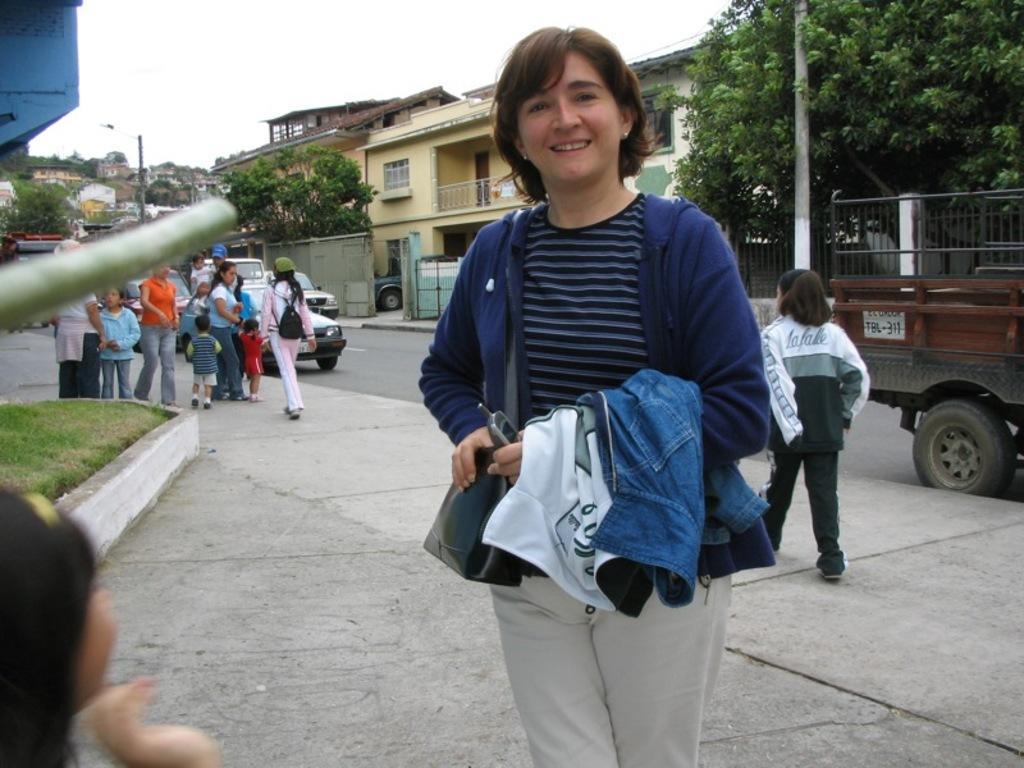Please provide a concise description of this image. In this image we can see a woman is standing, she is wearing the blue jacket, here a person is walking on the road, here are the group of people standing, here are the cars travelling on the road, here is the pole, where is the building, here is the gate, here is the window, here is the tree, at above here is the sky. 